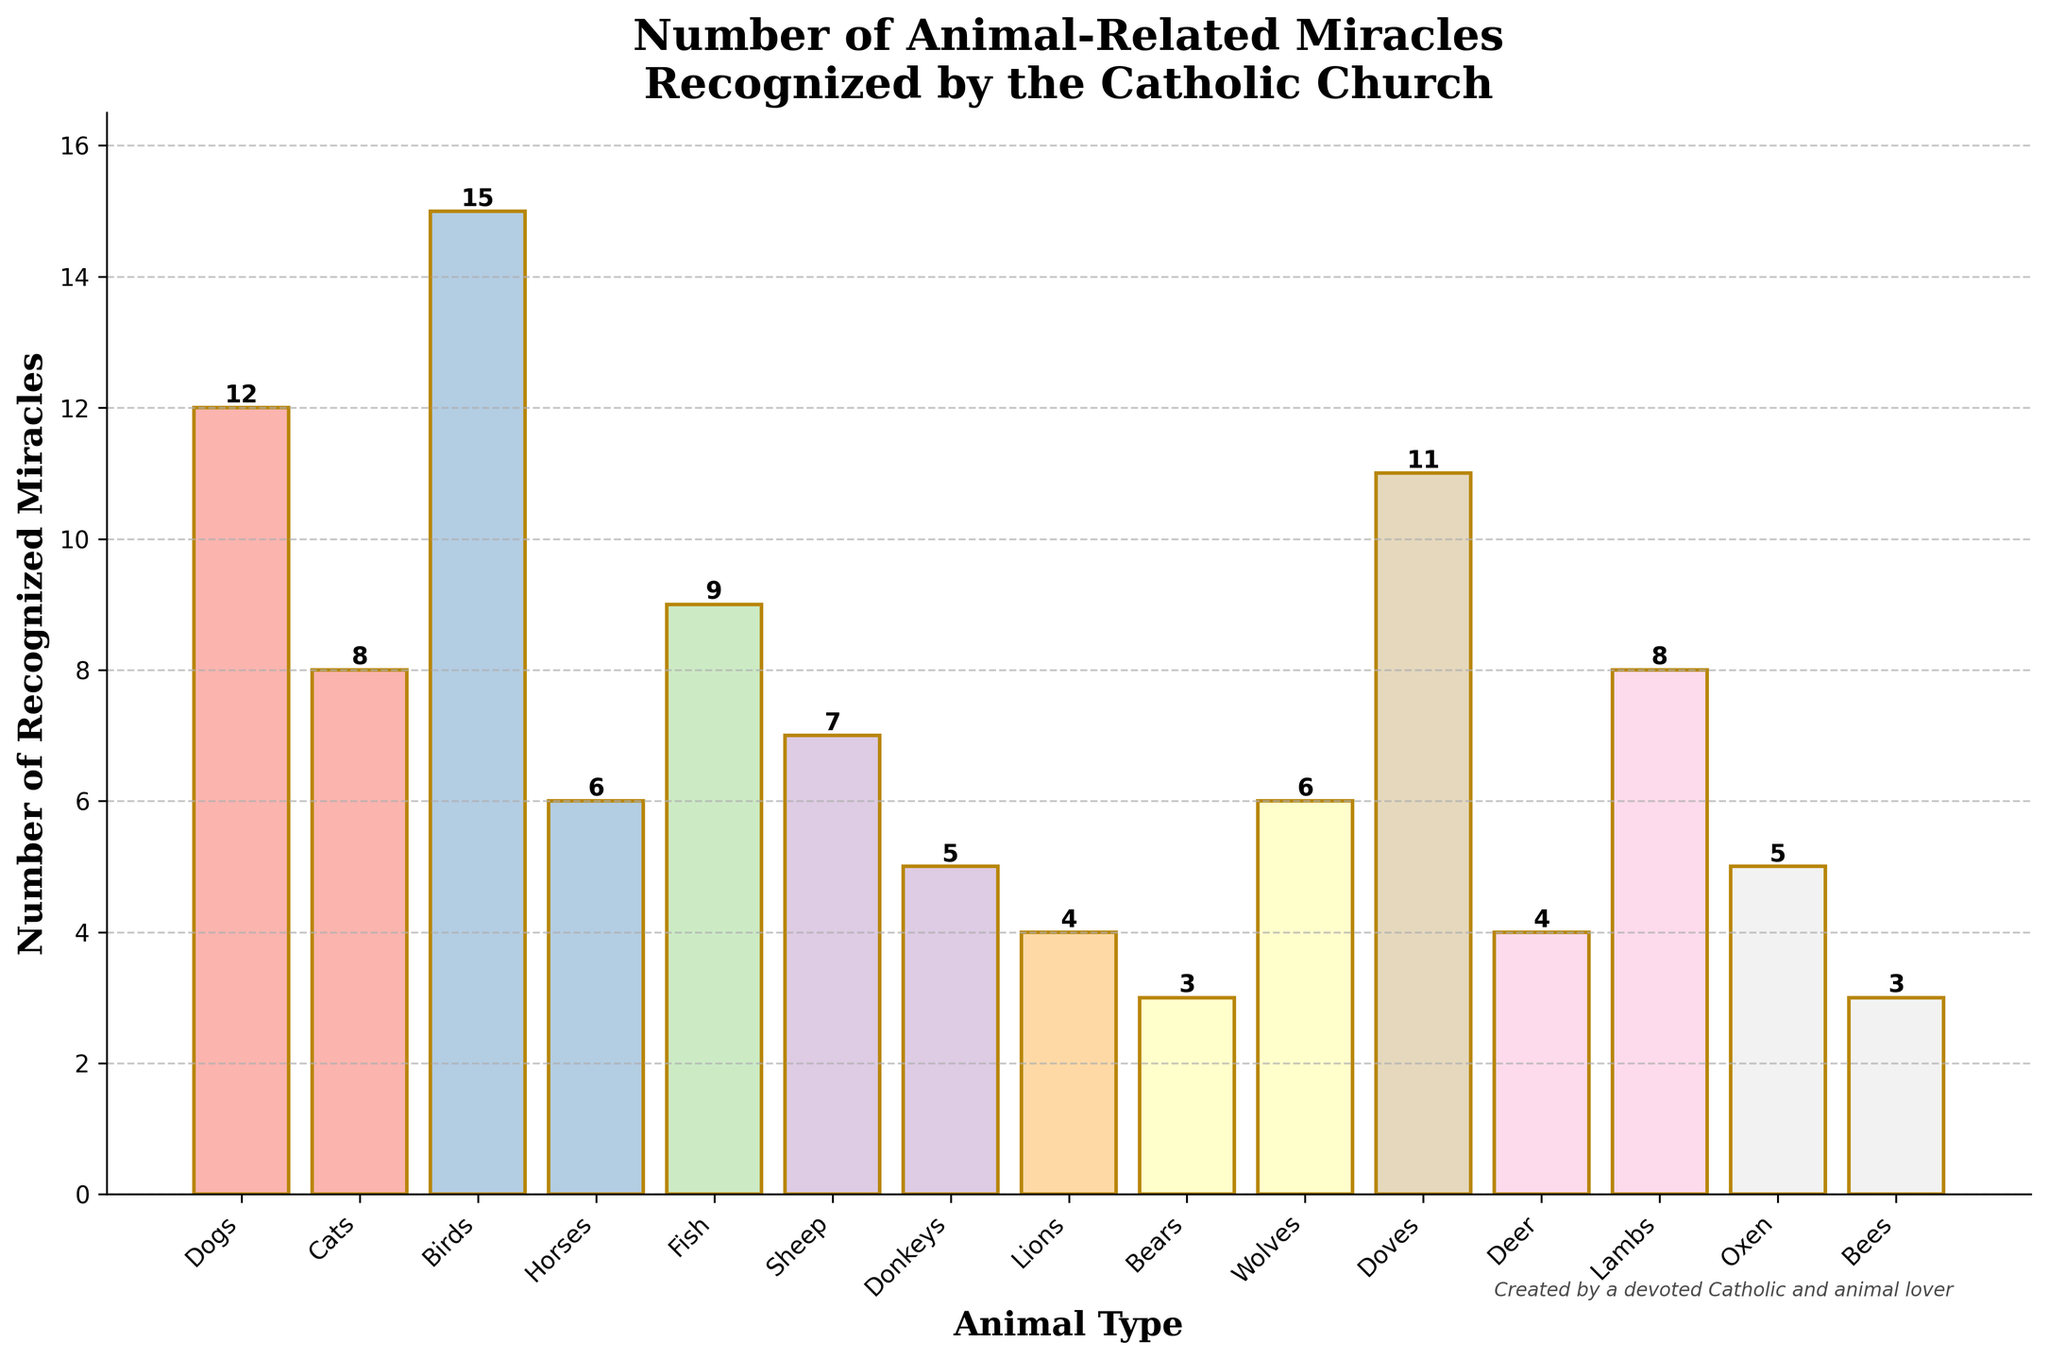Which animal type has the highest number of recognized miracles? To find the answer, look at the bar chart and identify the tallest bar. The tallest bar represents "Birds".
Answer: Birds How many more miracles are recognized for birds compared to bears? The number of recognized miracles for birds is 15, and for bears, it is 3. Subtracting these two values (15 - 3), we get 12.
Answer: 12 What is the total number of recognized miracles for wolves, deer, and donkeys combined? Add the numbers for wolves (6), deer (4), and donkeys (5). The total is 6 + 4 + 5 = 15.
Answer: 15 Which animals have an equal number of recognized miracles? Find bars of the same height in the chart. "Oxen" and "Donkeys" both have 5 miracles, and "Deer" and "Lions" both have 4 miracles.
Answer: Oxen and Donkeys; Deer and Lions What is the average number of recognized miracles for sheep, lambs, and fish? Add the numbers for sheep (7), lambs (8), and fish (9), then divide by 3. (7 + 8 + 9) / 3 = 24 / 3 = 8.
Answer: 8 How many animals have more than 10 recognized miracles? Identify the bars above the 10 mark. "Birds" (15), "Doves" (11), and "Dogs" (12) are above 10.
Answer: 3 What is the difference between the number of miracles for dogs and cats? Subtract the number of recognized miracles for cats (8) from dogs (12). 12 - 8 = 4.
Answer: 4 What is the median number of recognized miracles in the dataset? First, list all values in ascending order: [3, 3, 4, 4, 5, 5, 6, 6, 7, 8, 8, 9, 11, 12, 15]. The median value is the middle one: 7.
Answer: 7 Which animal type has exactly half the number of recognized miracles as dogs? Dogs have 12 recognized miracles, so half of 12 is 6. Check which animal has 6 miracles—"Horses" and "Wolves".
Answer: Horses and Wolves Which color bar represents doves, and how many miracles are recognized for them? The bar for "Doves" will be of the color used in the plotted figure, and it represents 11 recognized miracles.
Answer: Pastel color; 11 